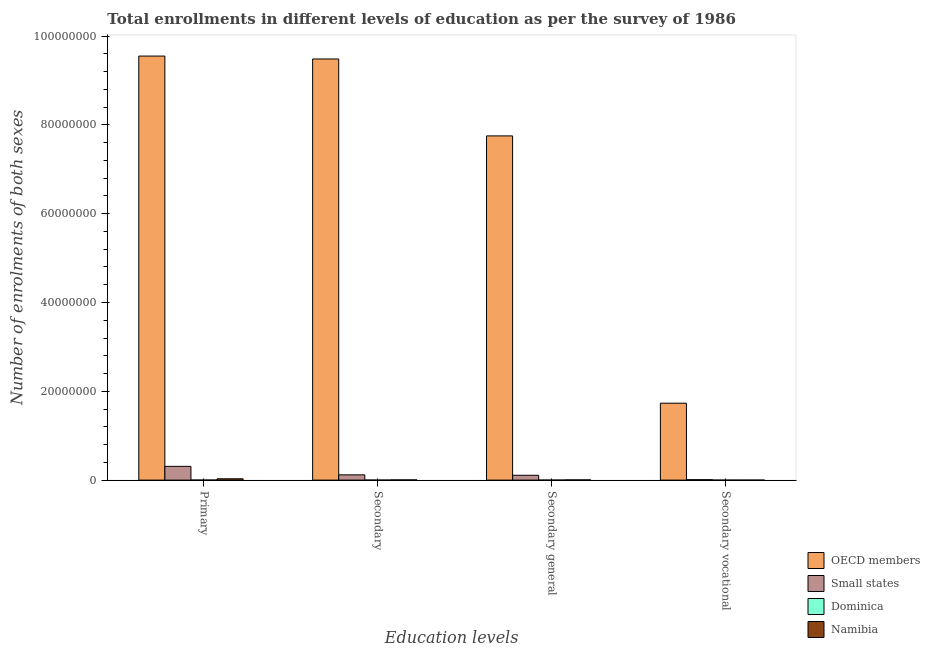How many different coloured bars are there?
Your answer should be very brief. 4. How many groups of bars are there?
Ensure brevity in your answer.  4. How many bars are there on the 4th tick from the left?
Offer a terse response. 4. How many bars are there on the 3rd tick from the right?
Your response must be concise. 4. What is the label of the 4th group of bars from the left?
Ensure brevity in your answer.  Secondary vocational. What is the number of enrolments in primary education in Namibia?
Your response must be concise. 2.95e+05. Across all countries, what is the maximum number of enrolments in primary education?
Offer a very short reply. 9.55e+07. Across all countries, what is the minimum number of enrolments in primary education?
Give a very brief answer. 1.23e+04. In which country was the number of enrolments in secondary vocational education minimum?
Your response must be concise. Namibia. What is the total number of enrolments in secondary general education in the graph?
Keep it short and to the point. 7.87e+07. What is the difference between the number of enrolments in secondary education in Namibia and that in Dominica?
Your response must be concise. 4.22e+04. What is the difference between the number of enrolments in secondary general education in Dominica and the number of enrolments in primary education in Namibia?
Keep it short and to the point. -2.88e+05. What is the average number of enrolments in secondary vocational education per country?
Offer a terse response. 4.35e+06. What is the difference between the number of enrolments in primary education and number of enrolments in secondary vocational education in Namibia?
Your answer should be very brief. 2.95e+05. In how many countries, is the number of enrolments in primary education greater than 48000000 ?
Give a very brief answer. 1. What is the ratio of the number of enrolments in secondary general education in OECD members to that in Small states?
Your answer should be very brief. 71.09. Is the number of enrolments in secondary vocational education in OECD members less than that in Namibia?
Your response must be concise. No. What is the difference between the highest and the second highest number of enrolments in secondary general education?
Offer a very short reply. 7.64e+07. What is the difference between the highest and the lowest number of enrolments in secondary vocational education?
Make the answer very short. 1.73e+07. Is the sum of the number of enrolments in primary education in Namibia and Dominica greater than the maximum number of enrolments in secondary vocational education across all countries?
Your response must be concise. No. What does the 1st bar from the left in Secondary vocational represents?
Ensure brevity in your answer.  OECD members. Is it the case that in every country, the sum of the number of enrolments in primary education and number of enrolments in secondary education is greater than the number of enrolments in secondary general education?
Give a very brief answer. Yes. How many bars are there?
Your response must be concise. 16. Are all the bars in the graph horizontal?
Your response must be concise. No. How many countries are there in the graph?
Provide a short and direct response. 4. What is the difference between two consecutive major ticks on the Y-axis?
Ensure brevity in your answer.  2.00e+07. Are the values on the major ticks of Y-axis written in scientific E-notation?
Give a very brief answer. No. Where does the legend appear in the graph?
Ensure brevity in your answer.  Bottom right. What is the title of the graph?
Your answer should be very brief. Total enrollments in different levels of education as per the survey of 1986. What is the label or title of the X-axis?
Provide a succinct answer. Education levels. What is the label or title of the Y-axis?
Make the answer very short. Number of enrolments of both sexes. What is the Number of enrolments of both sexes of OECD members in Primary?
Offer a very short reply. 9.55e+07. What is the Number of enrolments of both sexes in Small states in Primary?
Your answer should be very brief. 3.10e+06. What is the Number of enrolments of both sexes in Dominica in Primary?
Your answer should be compact. 1.23e+04. What is the Number of enrolments of both sexes in Namibia in Primary?
Your response must be concise. 2.95e+05. What is the Number of enrolments of both sexes in OECD members in Secondary?
Your answer should be very brief. 9.48e+07. What is the Number of enrolments of both sexes of Small states in Secondary?
Ensure brevity in your answer.  1.18e+06. What is the Number of enrolments of both sexes of Dominica in Secondary?
Provide a succinct answer. 7370. What is the Number of enrolments of both sexes of Namibia in Secondary?
Keep it short and to the point. 4.96e+04. What is the Number of enrolments of both sexes in OECD members in Secondary general?
Your response must be concise. 7.75e+07. What is the Number of enrolments of both sexes of Small states in Secondary general?
Offer a very short reply. 1.09e+06. What is the Number of enrolments of both sexes in Dominica in Secondary general?
Ensure brevity in your answer.  7111. What is the Number of enrolments of both sexes of Namibia in Secondary general?
Your answer should be compact. 4.94e+04. What is the Number of enrolments of both sexes in OECD members in Secondary vocational?
Ensure brevity in your answer.  1.73e+07. What is the Number of enrolments of both sexes of Small states in Secondary vocational?
Offer a very short reply. 9.37e+04. What is the Number of enrolments of both sexes in Dominica in Secondary vocational?
Your answer should be compact. 259. What is the Number of enrolments of both sexes in Namibia in Secondary vocational?
Offer a terse response. 154. Across all Education levels, what is the maximum Number of enrolments of both sexes in OECD members?
Make the answer very short. 9.55e+07. Across all Education levels, what is the maximum Number of enrolments of both sexes of Small states?
Your response must be concise. 3.10e+06. Across all Education levels, what is the maximum Number of enrolments of both sexes of Dominica?
Your answer should be very brief. 1.23e+04. Across all Education levels, what is the maximum Number of enrolments of both sexes of Namibia?
Make the answer very short. 2.95e+05. Across all Education levels, what is the minimum Number of enrolments of both sexes of OECD members?
Your answer should be very brief. 1.73e+07. Across all Education levels, what is the minimum Number of enrolments of both sexes of Small states?
Your answer should be compact. 9.37e+04. Across all Education levels, what is the minimum Number of enrolments of both sexes of Dominica?
Your answer should be compact. 259. Across all Education levels, what is the minimum Number of enrolments of both sexes in Namibia?
Provide a short and direct response. 154. What is the total Number of enrolments of both sexes of OECD members in the graph?
Provide a succinct answer. 2.85e+08. What is the total Number of enrolments of both sexes of Small states in the graph?
Ensure brevity in your answer.  5.47e+06. What is the total Number of enrolments of both sexes of Dominica in the graph?
Your response must be concise. 2.71e+04. What is the total Number of enrolments of both sexes in Namibia in the graph?
Your answer should be compact. 3.94e+05. What is the difference between the Number of enrolments of both sexes of OECD members in Primary and that in Secondary?
Your response must be concise. 6.54e+05. What is the difference between the Number of enrolments of both sexes of Small states in Primary and that in Secondary?
Your answer should be compact. 1.92e+06. What is the difference between the Number of enrolments of both sexes of Dominica in Primary and that in Secondary?
Your answer should be very brief. 4970. What is the difference between the Number of enrolments of both sexes of Namibia in Primary and that in Secondary?
Provide a succinct answer. 2.45e+05. What is the difference between the Number of enrolments of both sexes of OECD members in Primary and that in Secondary general?
Offer a very short reply. 1.80e+07. What is the difference between the Number of enrolments of both sexes in Small states in Primary and that in Secondary general?
Your answer should be very brief. 2.01e+06. What is the difference between the Number of enrolments of both sexes of Dominica in Primary and that in Secondary general?
Offer a terse response. 5229. What is the difference between the Number of enrolments of both sexes in Namibia in Primary and that in Secondary general?
Give a very brief answer. 2.46e+05. What is the difference between the Number of enrolments of both sexes of OECD members in Primary and that in Secondary vocational?
Provide a short and direct response. 7.82e+07. What is the difference between the Number of enrolments of both sexes of Small states in Primary and that in Secondary vocational?
Keep it short and to the point. 3.01e+06. What is the difference between the Number of enrolments of both sexes of Dominica in Primary and that in Secondary vocational?
Your answer should be compact. 1.21e+04. What is the difference between the Number of enrolments of both sexes in Namibia in Primary and that in Secondary vocational?
Ensure brevity in your answer.  2.95e+05. What is the difference between the Number of enrolments of both sexes of OECD members in Secondary and that in Secondary general?
Provide a succinct answer. 1.73e+07. What is the difference between the Number of enrolments of both sexes of Small states in Secondary and that in Secondary general?
Offer a terse response. 9.37e+04. What is the difference between the Number of enrolments of both sexes in Dominica in Secondary and that in Secondary general?
Provide a succinct answer. 259. What is the difference between the Number of enrolments of both sexes of Namibia in Secondary and that in Secondary general?
Your response must be concise. 154. What is the difference between the Number of enrolments of both sexes of OECD members in Secondary and that in Secondary vocational?
Provide a short and direct response. 7.75e+07. What is the difference between the Number of enrolments of both sexes of Small states in Secondary and that in Secondary vocational?
Make the answer very short. 1.09e+06. What is the difference between the Number of enrolments of both sexes of Dominica in Secondary and that in Secondary vocational?
Make the answer very short. 7111. What is the difference between the Number of enrolments of both sexes of Namibia in Secondary and that in Secondary vocational?
Provide a succinct answer. 4.94e+04. What is the difference between the Number of enrolments of both sexes in OECD members in Secondary general and that in Secondary vocational?
Ensure brevity in your answer.  6.02e+07. What is the difference between the Number of enrolments of both sexes in Small states in Secondary general and that in Secondary vocational?
Offer a very short reply. 9.97e+05. What is the difference between the Number of enrolments of both sexes in Dominica in Secondary general and that in Secondary vocational?
Give a very brief answer. 6852. What is the difference between the Number of enrolments of both sexes of Namibia in Secondary general and that in Secondary vocational?
Your answer should be compact. 4.93e+04. What is the difference between the Number of enrolments of both sexes in OECD members in Primary and the Number of enrolments of both sexes in Small states in Secondary?
Keep it short and to the point. 9.43e+07. What is the difference between the Number of enrolments of both sexes in OECD members in Primary and the Number of enrolments of both sexes in Dominica in Secondary?
Provide a succinct answer. 9.55e+07. What is the difference between the Number of enrolments of both sexes of OECD members in Primary and the Number of enrolments of both sexes of Namibia in Secondary?
Keep it short and to the point. 9.54e+07. What is the difference between the Number of enrolments of both sexes of Small states in Primary and the Number of enrolments of both sexes of Dominica in Secondary?
Your answer should be very brief. 3.09e+06. What is the difference between the Number of enrolments of both sexes of Small states in Primary and the Number of enrolments of both sexes of Namibia in Secondary?
Give a very brief answer. 3.05e+06. What is the difference between the Number of enrolments of both sexes of Dominica in Primary and the Number of enrolments of both sexes of Namibia in Secondary?
Offer a very short reply. -3.72e+04. What is the difference between the Number of enrolments of both sexes of OECD members in Primary and the Number of enrolments of both sexes of Small states in Secondary general?
Offer a very short reply. 9.44e+07. What is the difference between the Number of enrolments of both sexes in OECD members in Primary and the Number of enrolments of both sexes in Dominica in Secondary general?
Your answer should be compact. 9.55e+07. What is the difference between the Number of enrolments of both sexes in OECD members in Primary and the Number of enrolments of both sexes in Namibia in Secondary general?
Offer a terse response. 9.54e+07. What is the difference between the Number of enrolments of both sexes of Small states in Primary and the Number of enrolments of both sexes of Dominica in Secondary general?
Offer a very short reply. 3.09e+06. What is the difference between the Number of enrolments of both sexes in Small states in Primary and the Number of enrolments of both sexes in Namibia in Secondary general?
Ensure brevity in your answer.  3.05e+06. What is the difference between the Number of enrolments of both sexes of Dominica in Primary and the Number of enrolments of both sexes of Namibia in Secondary general?
Your answer should be compact. -3.71e+04. What is the difference between the Number of enrolments of both sexes of OECD members in Primary and the Number of enrolments of both sexes of Small states in Secondary vocational?
Your response must be concise. 9.54e+07. What is the difference between the Number of enrolments of both sexes in OECD members in Primary and the Number of enrolments of both sexes in Dominica in Secondary vocational?
Make the answer very short. 9.55e+07. What is the difference between the Number of enrolments of both sexes of OECD members in Primary and the Number of enrolments of both sexes of Namibia in Secondary vocational?
Your answer should be very brief. 9.55e+07. What is the difference between the Number of enrolments of both sexes in Small states in Primary and the Number of enrolments of both sexes in Dominica in Secondary vocational?
Ensure brevity in your answer.  3.10e+06. What is the difference between the Number of enrolments of both sexes of Small states in Primary and the Number of enrolments of both sexes of Namibia in Secondary vocational?
Your answer should be very brief. 3.10e+06. What is the difference between the Number of enrolments of both sexes in Dominica in Primary and the Number of enrolments of both sexes in Namibia in Secondary vocational?
Offer a terse response. 1.22e+04. What is the difference between the Number of enrolments of both sexes in OECD members in Secondary and the Number of enrolments of both sexes in Small states in Secondary general?
Your answer should be compact. 9.37e+07. What is the difference between the Number of enrolments of both sexes in OECD members in Secondary and the Number of enrolments of both sexes in Dominica in Secondary general?
Offer a very short reply. 9.48e+07. What is the difference between the Number of enrolments of both sexes of OECD members in Secondary and the Number of enrolments of both sexes of Namibia in Secondary general?
Your answer should be very brief. 9.48e+07. What is the difference between the Number of enrolments of both sexes of Small states in Secondary and the Number of enrolments of both sexes of Dominica in Secondary general?
Provide a succinct answer. 1.18e+06. What is the difference between the Number of enrolments of both sexes in Small states in Secondary and the Number of enrolments of both sexes in Namibia in Secondary general?
Offer a terse response. 1.13e+06. What is the difference between the Number of enrolments of both sexes of Dominica in Secondary and the Number of enrolments of both sexes of Namibia in Secondary general?
Make the answer very short. -4.20e+04. What is the difference between the Number of enrolments of both sexes of OECD members in Secondary and the Number of enrolments of both sexes of Small states in Secondary vocational?
Give a very brief answer. 9.47e+07. What is the difference between the Number of enrolments of both sexes of OECD members in Secondary and the Number of enrolments of both sexes of Dominica in Secondary vocational?
Make the answer very short. 9.48e+07. What is the difference between the Number of enrolments of both sexes of OECD members in Secondary and the Number of enrolments of both sexes of Namibia in Secondary vocational?
Keep it short and to the point. 9.48e+07. What is the difference between the Number of enrolments of both sexes of Small states in Secondary and the Number of enrolments of both sexes of Dominica in Secondary vocational?
Your answer should be compact. 1.18e+06. What is the difference between the Number of enrolments of both sexes in Small states in Secondary and the Number of enrolments of both sexes in Namibia in Secondary vocational?
Offer a terse response. 1.18e+06. What is the difference between the Number of enrolments of both sexes of Dominica in Secondary and the Number of enrolments of both sexes of Namibia in Secondary vocational?
Offer a very short reply. 7216. What is the difference between the Number of enrolments of both sexes of OECD members in Secondary general and the Number of enrolments of both sexes of Small states in Secondary vocational?
Offer a terse response. 7.74e+07. What is the difference between the Number of enrolments of both sexes in OECD members in Secondary general and the Number of enrolments of both sexes in Dominica in Secondary vocational?
Your answer should be very brief. 7.75e+07. What is the difference between the Number of enrolments of both sexes in OECD members in Secondary general and the Number of enrolments of both sexes in Namibia in Secondary vocational?
Provide a succinct answer. 7.75e+07. What is the difference between the Number of enrolments of both sexes of Small states in Secondary general and the Number of enrolments of both sexes of Dominica in Secondary vocational?
Give a very brief answer. 1.09e+06. What is the difference between the Number of enrolments of both sexes in Small states in Secondary general and the Number of enrolments of both sexes in Namibia in Secondary vocational?
Provide a succinct answer. 1.09e+06. What is the difference between the Number of enrolments of both sexes in Dominica in Secondary general and the Number of enrolments of both sexes in Namibia in Secondary vocational?
Provide a succinct answer. 6957. What is the average Number of enrolments of both sexes in OECD members per Education levels?
Provide a short and direct response. 7.13e+07. What is the average Number of enrolments of both sexes in Small states per Education levels?
Ensure brevity in your answer.  1.37e+06. What is the average Number of enrolments of both sexes of Dominica per Education levels?
Your answer should be compact. 6770. What is the average Number of enrolments of both sexes in Namibia per Education levels?
Provide a short and direct response. 9.85e+04. What is the difference between the Number of enrolments of both sexes of OECD members and Number of enrolments of both sexes of Small states in Primary?
Keep it short and to the point. 9.24e+07. What is the difference between the Number of enrolments of both sexes of OECD members and Number of enrolments of both sexes of Dominica in Primary?
Provide a short and direct response. 9.55e+07. What is the difference between the Number of enrolments of both sexes in OECD members and Number of enrolments of both sexes in Namibia in Primary?
Make the answer very short. 9.52e+07. What is the difference between the Number of enrolments of both sexes of Small states and Number of enrolments of both sexes of Dominica in Primary?
Keep it short and to the point. 3.09e+06. What is the difference between the Number of enrolments of both sexes of Small states and Number of enrolments of both sexes of Namibia in Primary?
Keep it short and to the point. 2.80e+06. What is the difference between the Number of enrolments of both sexes of Dominica and Number of enrolments of both sexes of Namibia in Primary?
Give a very brief answer. -2.83e+05. What is the difference between the Number of enrolments of both sexes of OECD members and Number of enrolments of both sexes of Small states in Secondary?
Give a very brief answer. 9.36e+07. What is the difference between the Number of enrolments of both sexes in OECD members and Number of enrolments of both sexes in Dominica in Secondary?
Provide a succinct answer. 9.48e+07. What is the difference between the Number of enrolments of both sexes in OECD members and Number of enrolments of both sexes in Namibia in Secondary?
Offer a terse response. 9.48e+07. What is the difference between the Number of enrolments of both sexes in Small states and Number of enrolments of both sexes in Dominica in Secondary?
Make the answer very short. 1.18e+06. What is the difference between the Number of enrolments of both sexes in Small states and Number of enrolments of both sexes in Namibia in Secondary?
Offer a terse response. 1.13e+06. What is the difference between the Number of enrolments of both sexes of Dominica and Number of enrolments of both sexes of Namibia in Secondary?
Your answer should be compact. -4.22e+04. What is the difference between the Number of enrolments of both sexes of OECD members and Number of enrolments of both sexes of Small states in Secondary general?
Your response must be concise. 7.64e+07. What is the difference between the Number of enrolments of both sexes in OECD members and Number of enrolments of both sexes in Dominica in Secondary general?
Your answer should be very brief. 7.75e+07. What is the difference between the Number of enrolments of both sexes of OECD members and Number of enrolments of both sexes of Namibia in Secondary general?
Give a very brief answer. 7.75e+07. What is the difference between the Number of enrolments of both sexes in Small states and Number of enrolments of both sexes in Dominica in Secondary general?
Provide a short and direct response. 1.08e+06. What is the difference between the Number of enrolments of both sexes of Small states and Number of enrolments of both sexes of Namibia in Secondary general?
Keep it short and to the point. 1.04e+06. What is the difference between the Number of enrolments of both sexes in Dominica and Number of enrolments of both sexes in Namibia in Secondary general?
Offer a very short reply. -4.23e+04. What is the difference between the Number of enrolments of both sexes in OECD members and Number of enrolments of both sexes in Small states in Secondary vocational?
Your response must be concise. 1.72e+07. What is the difference between the Number of enrolments of both sexes in OECD members and Number of enrolments of both sexes in Dominica in Secondary vocational?
Offer a terse response. 1.73e+07. What is the difference between the Number of enrolments of both sexes of OECD members and Number of enrolments of both sexes of Namibia in Secondary vocational?
Your answer should be very brief. 1.73e+07. What is the difference between the Number of enrolments of both sexes in Small states and Number of enrolments of both sexes in Dominica in Secondary vocational?
Offer a very short reply. 9.34e+04. What is the difference between the Number of enrolments of both sexes of Small states and Number of enrolments of both sexes of Namibia in Secondary vocational?
Offer a terse response. 9.35e+04. What is the difference between the Number of enrolments of both sexes in Dominica and Number of enrolments of both sexes in Namibia in Secondary vocational?
Make the answer very short. 105. What is the ratio of the Number of enrolments of both sexes in OECD members in Primary to that in Secondary?
Your answer should be very brief. 1.01. What is the ratio of the Number of enrolments of both sexes of Small states in Primary to that in Secondary?
Your response must be concise. 2.62. What is the ratio of the Number of enrolments of both sexes of Dominica in Primary to that in Secondary?
Your answer should be very brief. 1.67. What is the ratio of the Number of enrolments of both sexes in Namibia in Primary to that in Secondary?
Make the answer very short. 5.95. What is the ratio of the Number of enrolments of both sexes in OECD members in Primary to that in Secondary general?
Your response must be concise. 1.23. What is the ratio of the Number of enrolments of both sexes of Small states in Primary to that in Secondary general?
Your answer should be compact. 2.84. What is the ratio of the Number of enrolments of both sexes of Dominica in Primary to that in Secondary general?
Offer a terse response. 1.74. What is the ratio of the Number of enrolments of both sexes in Namibia in Primary to that in Secondary general?
Your response must be concise. 5.97. What is the ratio of the Number of enrolments of both sexes in OECD members in Primary to that in Secondary vocational?
Your response must be concise. 5.51. What is the ratio of the Number of enrolments of both sexes in Small states in Primary to that in Secondary vocational?
Give a very brief answer. 33.1. What is the ratio of the Number of enrolments of both sexes in Dominica in Primary to that in Secondary vocational?
Offer a terse response. 47.64. What is the ratio of the Number of enrolments of both sexes of Namibia in Primary to that in Secondary vocational?
Offer a very short reply. 1915.49. What is the ratio of the Number of enrolments of both sexes of OECD members in Secondary to that in Secondary general?
Offer a terse response. 1.22. What is the ratio of the Number of enrolments of both sexes of Small states in Secondary to that in Secondary general?
Keep it short and to the point. 1.09. What is the ratio of the Number of enrolments of both sexes of Dominica in Secondary to that in Secondary general?
Offer a very short reply. 1.04. What is the ratio of the Number of enrolments of both sexes of Namibia in Secondary to that in Secondary general?
Offer a very short reply. 1. What is the ratio of the Number of enrolments of both sexes in OECD members in Secondary to that in Secondary vocational?
Keep it short and to the point. 5.47. What is the ratio of the Number of enrolments of both sexes in Small states in Secondary to that in Secondary vocational?
Give a very brief answer. 12.64. What is the ratio of the Number of enrolments of both sexes of Dominica in Secondary to that in Secondary vocational?
Your answer should be very brief. 28.46. What is the ratio of the Number of enrolments of both sexes in Namibia in Secondary to that in Secondary vocational?
Ensure brevity in your answer.  321.89. What is the ratio of the Number of enrolments of both sexes in OECD members in Secondary general to that in Secondary vocational?
Keep it short and to the point. 4.47. What is the ratio of the Number of enrolments of both sexes in Small states in Secondary general to that in Secondary vocational?
Keep it short and to the point. 11.64. What is the ratio of the Number of enrolments of both sexes in Dominica in Secondary general to that in Secondary vocational?
Offer a terse response. 27.46. What is the ratio of the Number of enrolments of both sexes of Namibia in Secondary general to that in Secondary vocational?
Your response must be concise. 320.89. What is the difference between the highest and the second highest Number of enrolments of both sexes in OECD members?
Keep it short and to the point. 6.54e+05. What is the difference between the highest and the second highest Number of enrolments of both sexes of Small states?
Offer a very short reply. 1.92e+06. What is the difference between the highest and the second highest Number of enrolments of both sexes in Dominica?
Give a very brief answer. 4970. What is the difference between the highest and the second highest Number of enrolments of both sexes of Namibia?
Provide a succinct answer. 2.45e+05. What is the difference between the highest and the lowest Number of enrolments of both sexes in OECD members?
Give a very brief answer. 7.82e+07. What is the difference between the highest and the lowest Number of enrolments of both sexes of Small states?
Provide a short and direct response. 3.01e+06. What is the difference between the highest and the lowest Number of enrolments of both sexes of Dominica?
Your response must be concise. 1.21e+04. What is the difference between the highest and the lowest Number of enrolments of both sexes of Namibia?
Provide a short and direct response. 2.95e+05. 